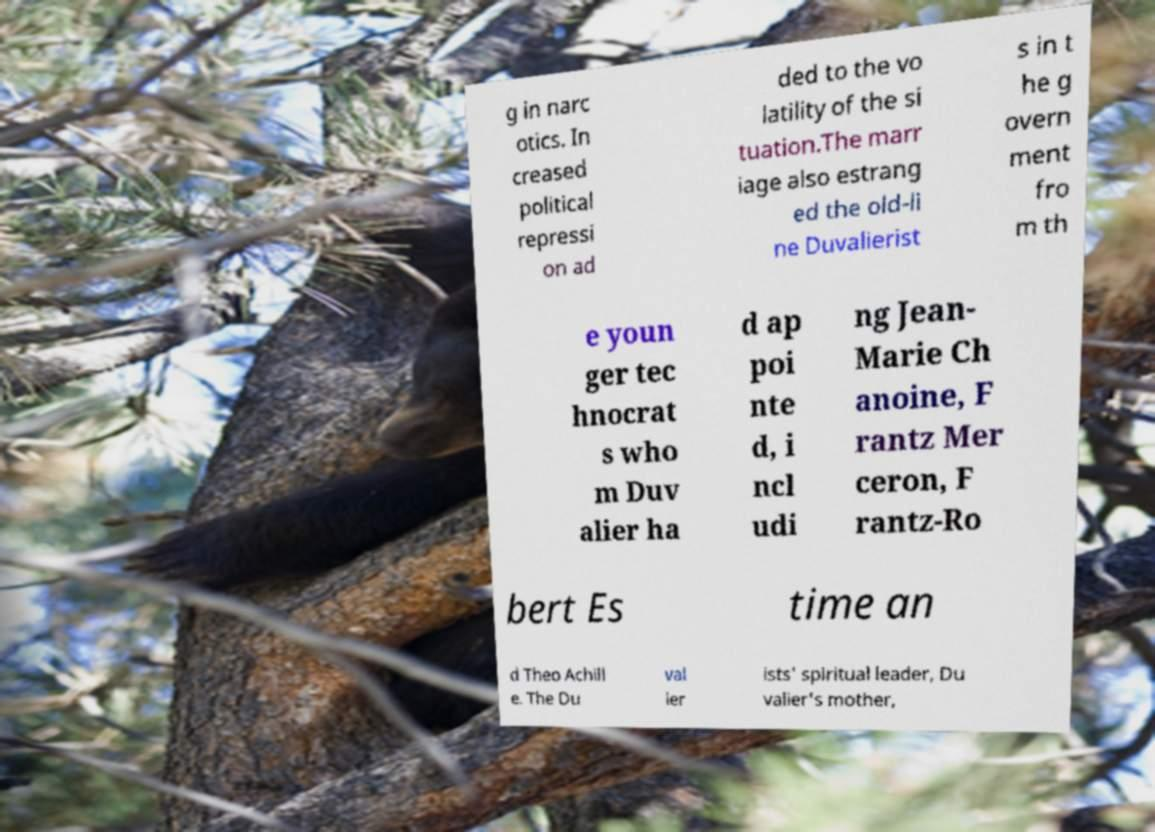There's text embedded in this image that I need extracted. Can you transcribe it verbatim? g in narc otics. In creased political repressi on ad ded to the vo latility of the si tuation.The marr iage also estrang ed the old-li ne Duvalierist s in t he g overn ment fro m th e youn ger tec hnocrat s who m Duv alier ha d ap poi nte d, i ncl udi ng Jean- Marie Ch anoine, F rantz Mer ceron, F rantz-Ro bert Es time an d Theo Achill e. The Du val ier ists' spiritual leader, Du valier's mother, 